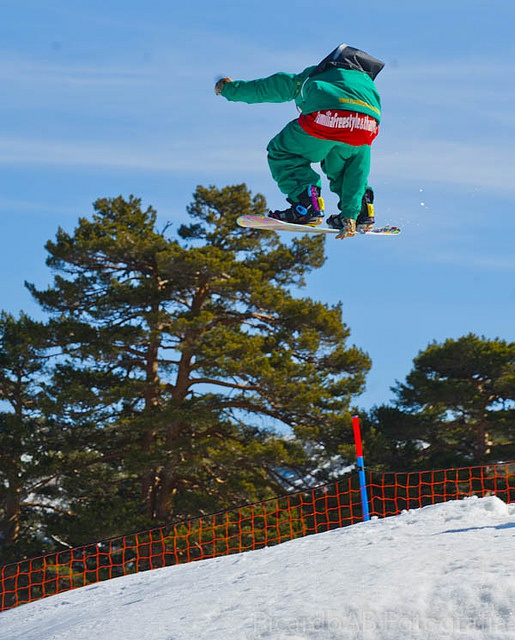Describe the objects in this image and their specific colors. I can see people in lightblue, teal, black, and turquoise tones, snowboard in lightblue, darkgray, tan, lightgray, and violet tones, and snowboard in lightblue, gray, darkgray, and lightgray tones in this image. 